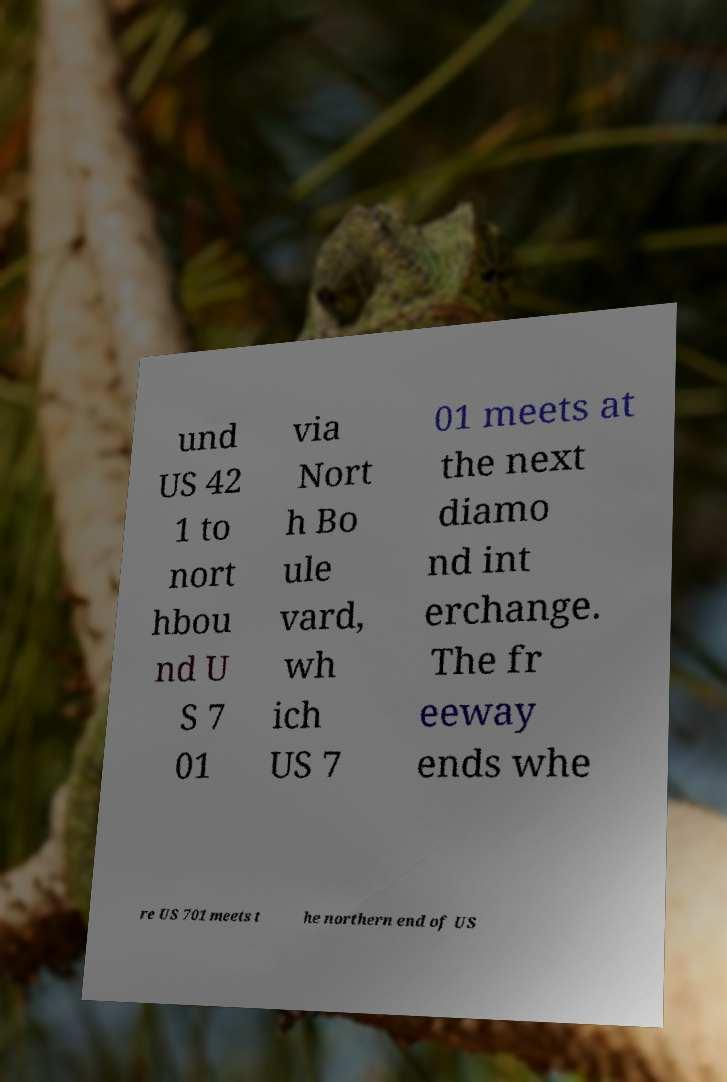Please identify and transcribe the text found in this image. und US 42 1 to nort hbou nd U S 7 01 via Nort h Bo ule vard, wh ich US 7 01 meets at the next diamo nd int erchange. The fr eeway ends whe re US 701 meets t he northern end of US 